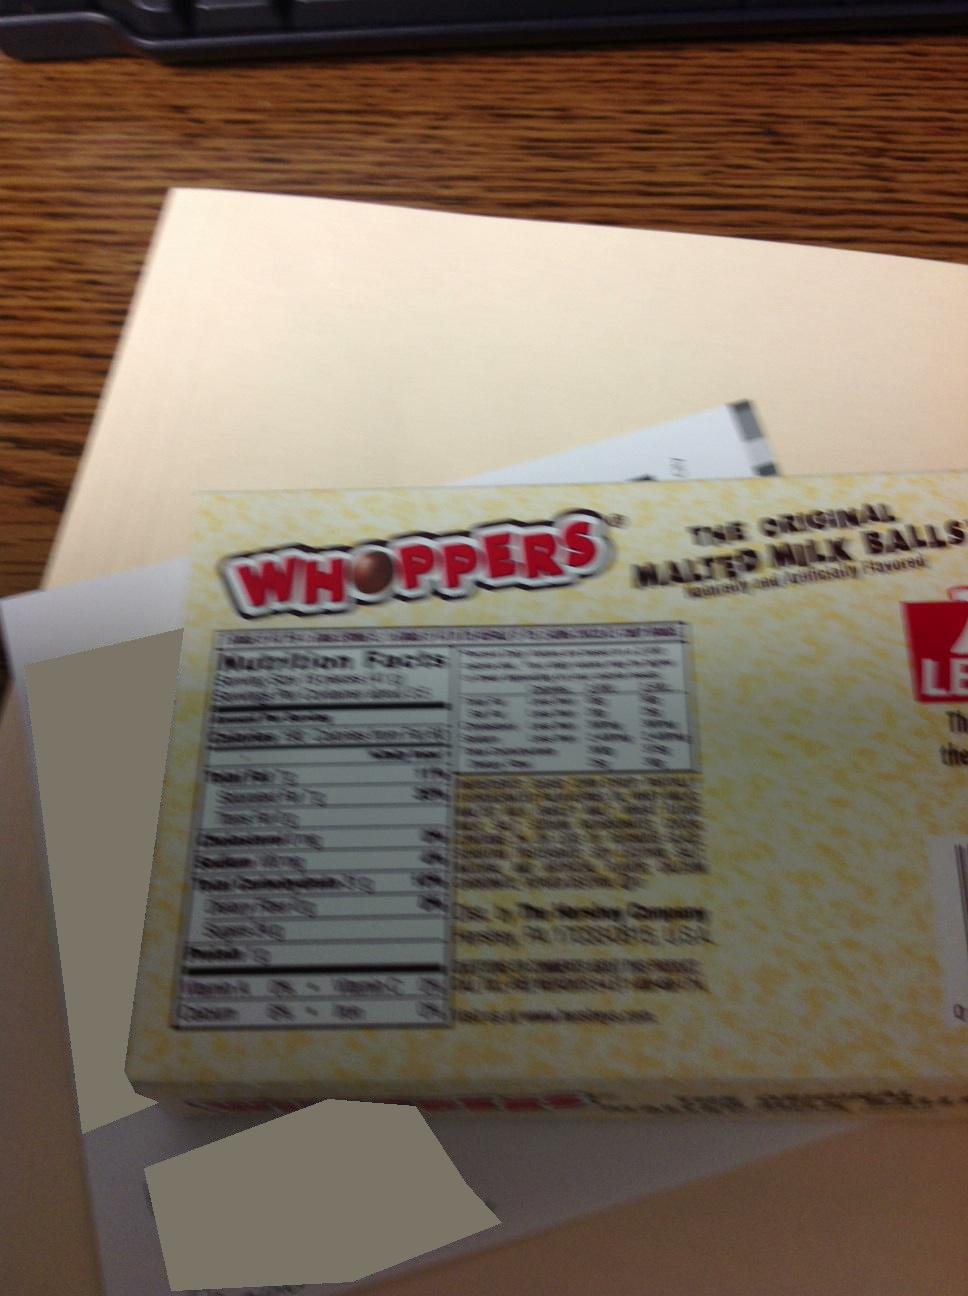Can you tell what product is inside this box? The box contains Whoppers, the original malted milk balls, as indicated by the visible packaging. 